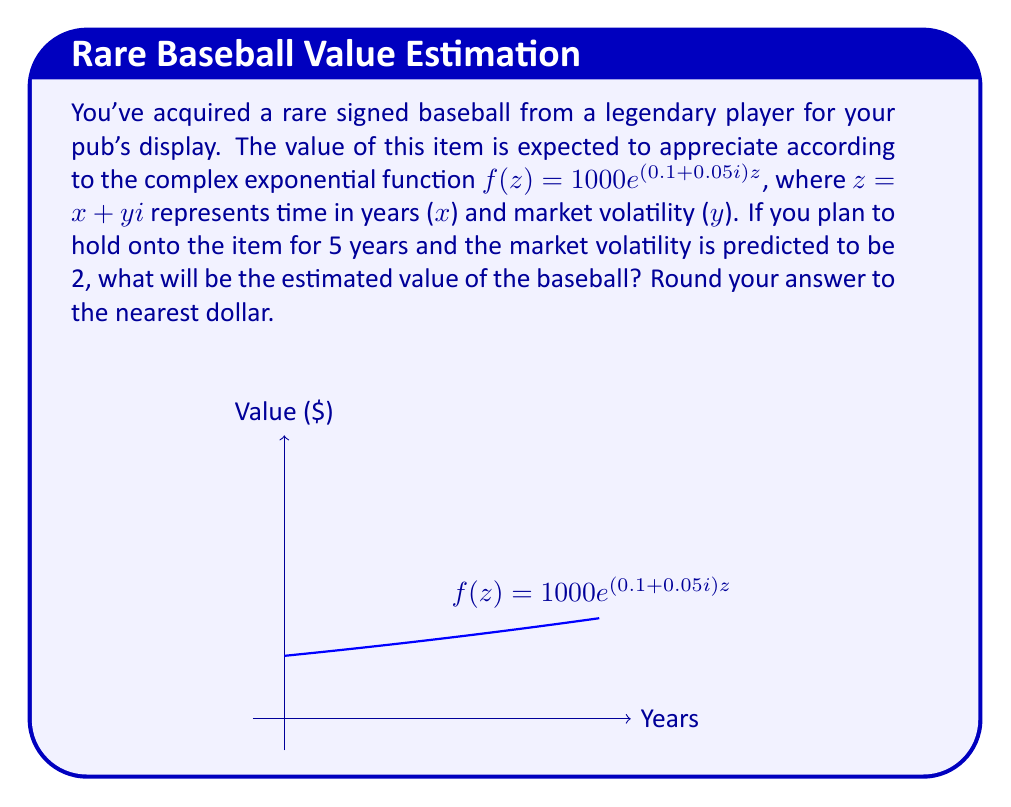Can you answer this question? Let's approach this step-by-step:

1) We're given the function $f(z) = 1000e^{(0.1+0.05i)z}$, where $z = x + yi$.

2) We need to calculate the value after 5 years with a market volatility of 2. This means we need to evaluate $f(5+2i)$.

3) Let's substitute these values:

   $f(5+2i) = 1000e^{(0.1+0.05i)(5+2i)}$

4) Simplify the exponent:
   $(0.1+0.05i)(5+2i) = 0.5+0.2i+0.25i-0.1 = 0.4+0.45i$

5) Now we have:
   $f(5+2i) = 1000e^{0.4+0.45i}$

6) To evaluate this, we can use Euler's formula: $e^{a+bi} = e^a(\cos b + i\sin b)$

7) In our case, $a=0.4$ and $b=0.45$:
   $1000e^{0.4+0.45i} = 1000e^{0.4}(\cos 0.45 + i\sin 0.45)$

8) Calculate:
   $e^{0.4} \approx 1.4918$
   $\cos 0.45 \approx 0.9005$
   $\sin 0.45 \approx 0.4348$

9) Substituting:
   $1000 * 1.4918 * (0.9005 + 0.4348i) \approx 1343.32 + 648.58i$

10) The value we're interested in is the magnitude of this complex number:
    $\sqrt{1343.32^2 + 648.58^2} \approx 1491.87$

11) Rounding to the nearest dollar: $1492
Answer: $1492 